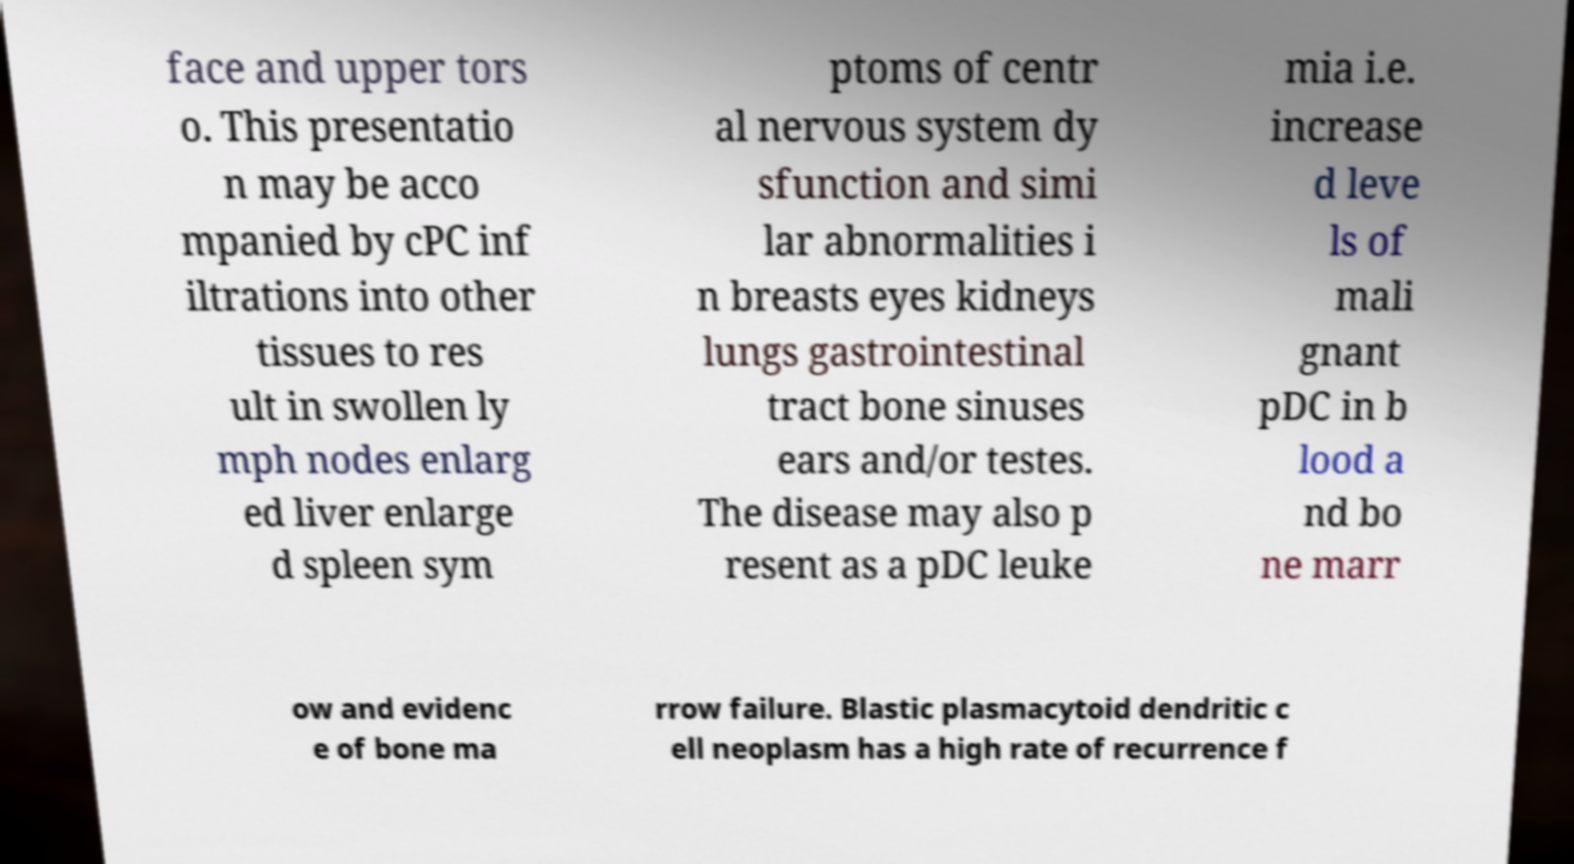For documentation purposes, I need the text within this image transcribed. Could you provide that? face and upper tors o. This presentatio n may be acco mpanied by cPC inf iltrations into other tissues to res ult in swollen ly mph nodes enlarg ed liver enlarge d spleen sym ptoms of centr al nervous system dy sfunction and simi lar abnormalities i n breasts eyes kidneys lungs gastrointestinal tract bone sinuses ears and/or testes. The disease may also p resent as a pDC leuke mia i.e. increase d leve ls of mali gnant pDC in b lood a nd bo ne marr ow and evidenc e of bone ma rrow failure. Blastic plasmacytoid dendritic c ell neoplasm has a high rate of recurrence f 